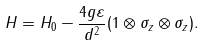Convert formula to latex. <formula><loc_0><loc_0><loc_500><loc_500>H = H _ { 0 } - \frac { 4 g \varepsilon } { d ^ { 2 } } ( 1 \otimes \sigma _ { z } \otimes \sigma _ { z } ) .</formula> 